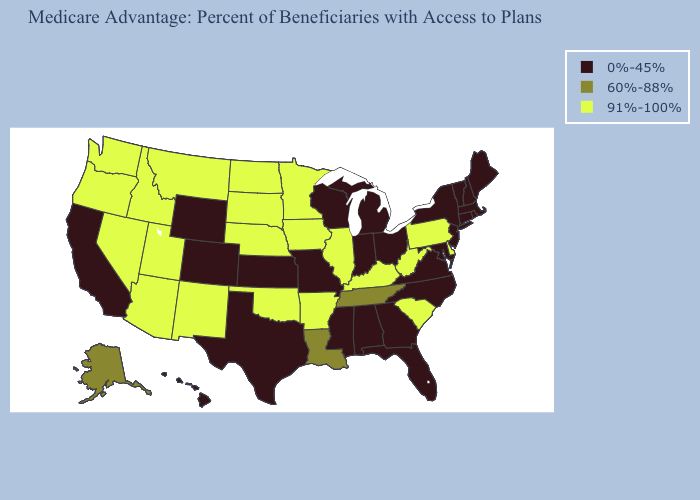Name the states that have a value in the range 91%-100%?
Give a very brief answer. Arkansas, Arizona, Delaware, Iowa, Idaho, Illinois, Kentucky, Minnesota, Montana, North Dakota, Nebraska, New Mexico, Nevada, Oklahoma, Oregon, Pennsylvania, South Carolina, South Dakota, Utah, Washington, West Virginia. Among the states that border North Carolina , does Tennessee have the lowest value?
Concise answer only. No. Name the states that have a value in the range 0%-45%?
Be succinct. Alabama, California, Colorado, Connecticut, Florida, Georgia, Hawaii, Indiana, Kansas, Massachusetts, Maryland, Maine, Michigan, Missouri, Mississippi, North Carolina, New Hampshire, New Jersey, New York, Ohio, Rhode Island, Texas, Virginia, Vermont, Wisconsin, Wyoming. What is the value of Idaho?
Quick response, please. 91%-100%. Among the states that border Wyoming , which have the highest value?
Keep it brief. Idaho, Montana, Nebraska, South Dakota, Utah. Does the first symbol in the legend represent the smallest category?
Be succinct. Yes. What is the value of Mississippi?
Keep it brief. 0%-45%. What is the value of Michigan?
Be succinct. 0%-45%. What is the highest value in the MidWest ?
Be succinct. 91%-100%. Which states hav the highest value in the Northeast?
Short answer required. Pennsylvania. What is the value of Michigan?
Concise answer only. 0%-45%. Is the legend a continuous bar?
Write a very short answer. No. What is the highest value in the USA?
Quick response, please. 91%-100%. Name the states that have a value in the range 91%-100%?
Be succinct. Arkansas, Arizona, Delaware, Iowa, Idaho, Illinois, Kentucky, Minnesota, Montana, North Dakota, Nebraska, New Mexico, Nevada, Oklahoma, Oregon, Pennsylvania, South Carolina, South Dakota, Utah, Washington, West Virginia. Does the first symbol in the legend represent the smallest category?
Quick response, please. Yes. 